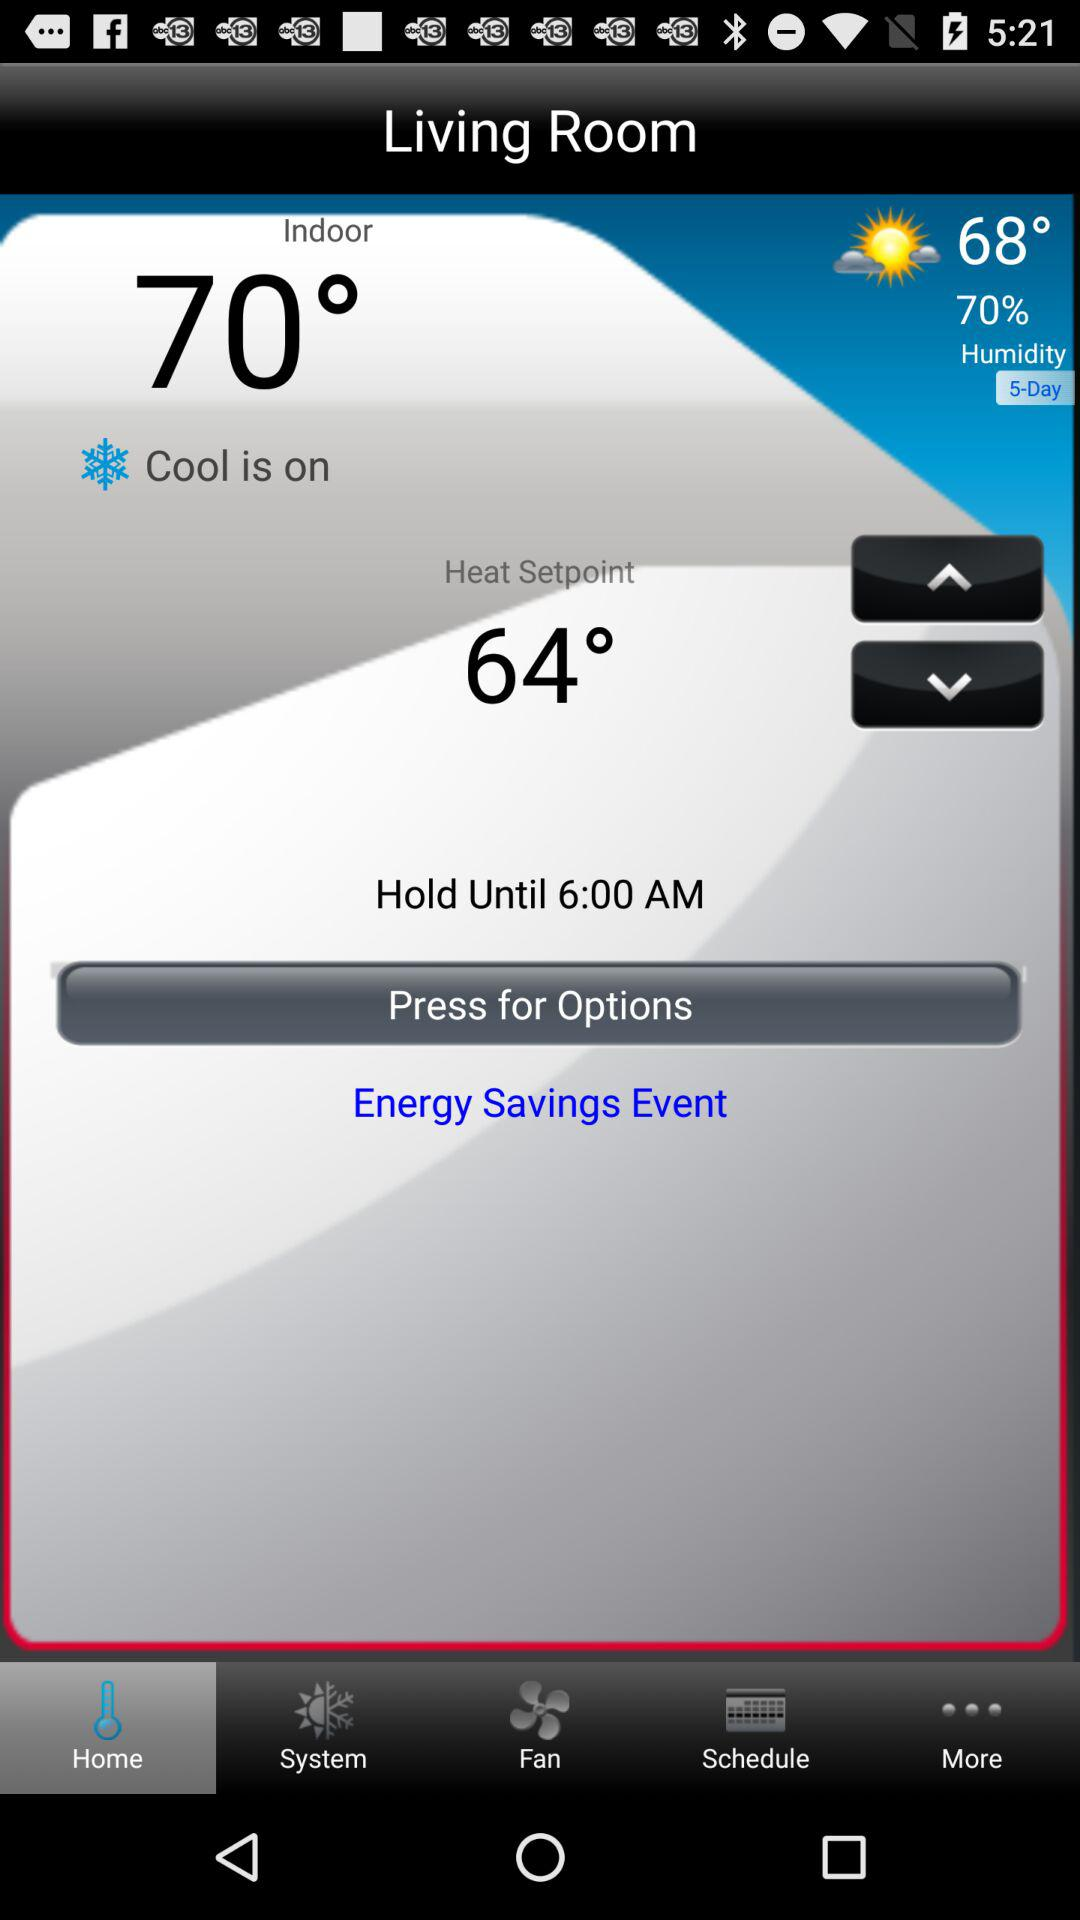What is the shown time? The shown time is 6:00 AM. 